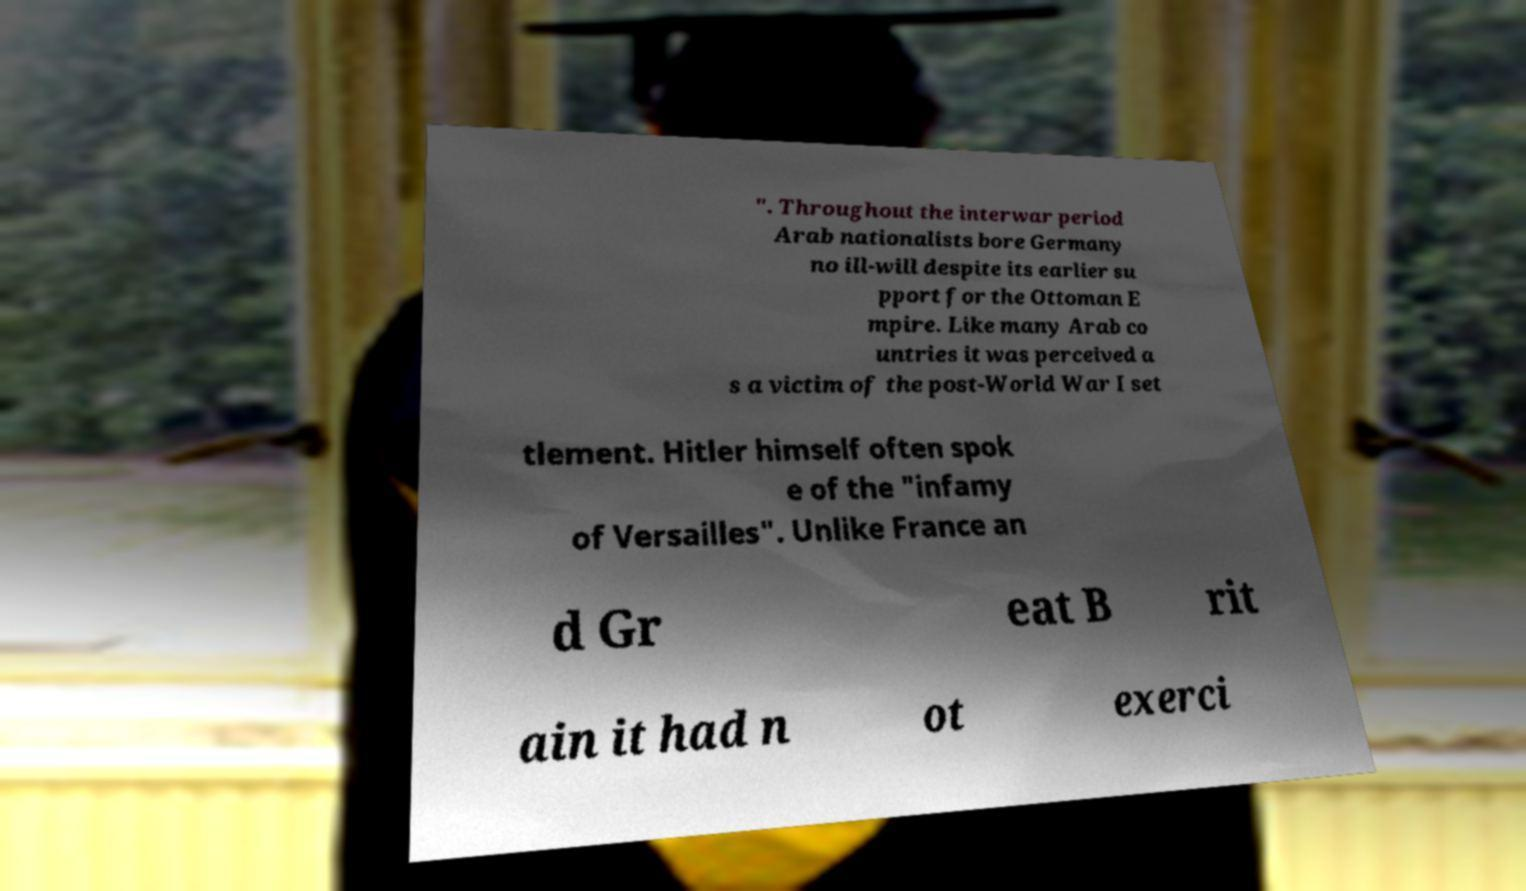Please read and relay the text visible in this image. What does it say? ". Throughout the interwar period Arab nationalists bore Germany no ill-will despite its earlier su pport for the Ottoman E mpire. Like many Arab co untries it was perceived a s a victim of the post-World War I set tlement. Hitler himself often spok e of the "infamy of Versailles". Unlike France an d Gr eat B rit ain it had n ot exerci 